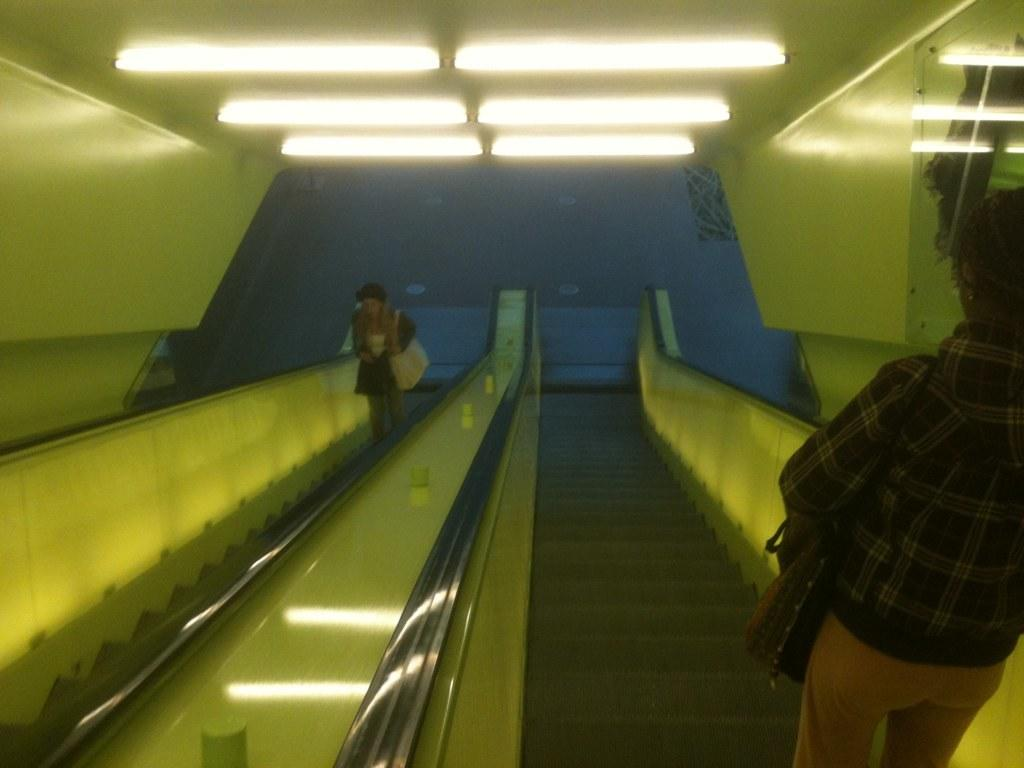How many people are in the image? There are two persons in the image. What are the persons wearing? The persons are wearing clothes. What are the persons doing in the image? The persons are standing on escalators. What can be seen at the top of the image? There are lights at the top of the image. What is the level of debt for the persons in the image? There is no information about the persons' debt in the image. How quiet is the environment in the image? The level of noise or quietness cannot be determined from the image. 